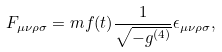<formula> <loc_0><loc_0><loc_500><loc_500>F _ { \mu \nu \rho \sigma } = m f ( t ) \frac { 1 } { \sqrt { - g ^ { ( 4 ) } } } \epsilon _ { \mu \nu \rho \sigma } ,</formula> 